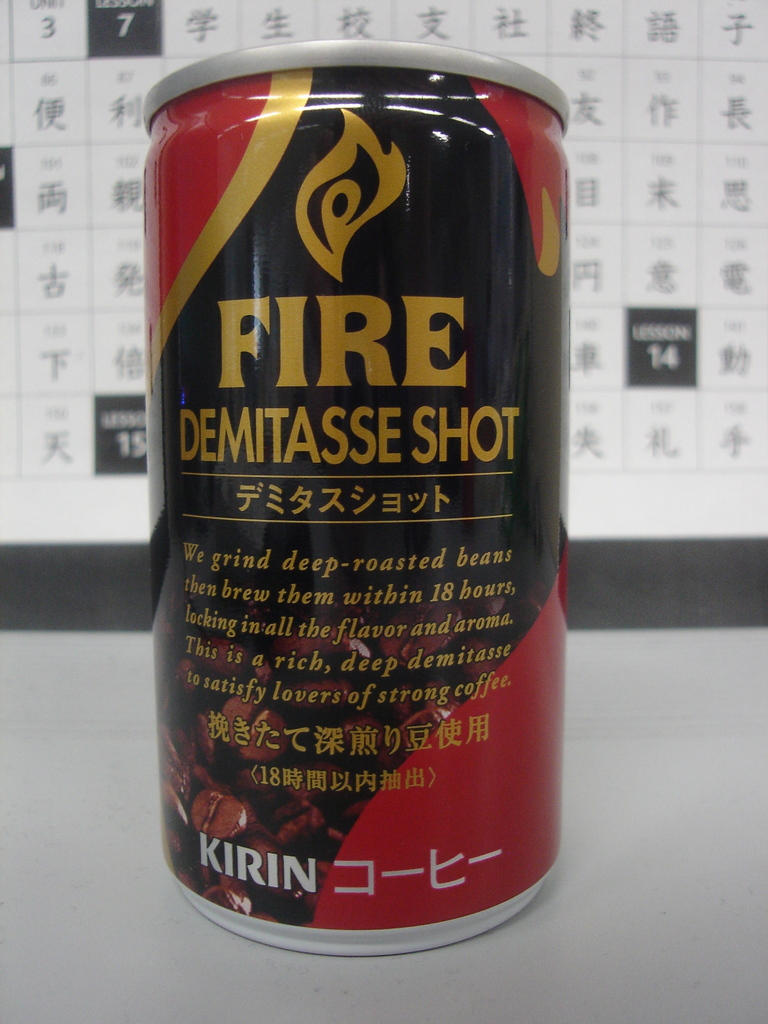What can you tell about the branding strategy seen on the can's design? The branding strategy for Kirin's Fire Demitasse Shot utilizes bold colors and dynamic fonts to evoke a sense of energy and intensity. The use of the flame symbol in conjunction with the name 'Fire' emphasizes the product's strong, robust nature, aiming to attract consumers who appreciate a potent, invigorating coffee experience. 